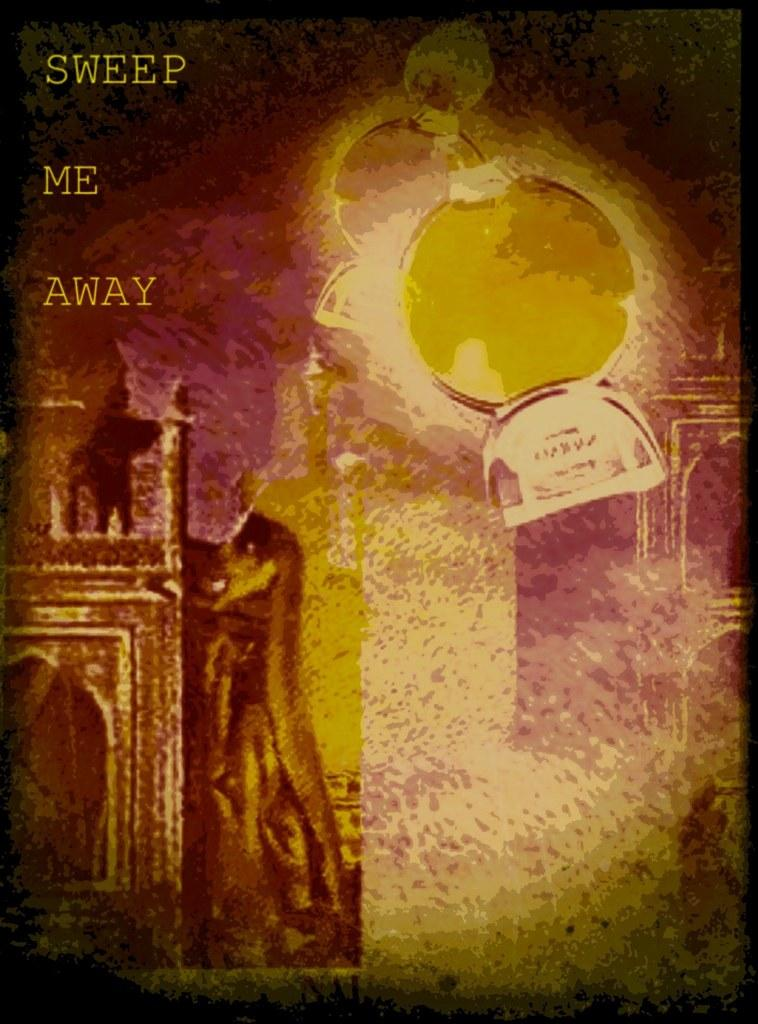<image>
Relay a brief, clear account of the picture shown. The poster shown has the words Sweep me Away written on it. 